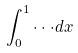Convert formula to latex. <formula><loc_0><loc_0><loc_500><loc_500>\int _ { 0 } ^ { 1 } \cdot \cdot \cdot d x</formula> 